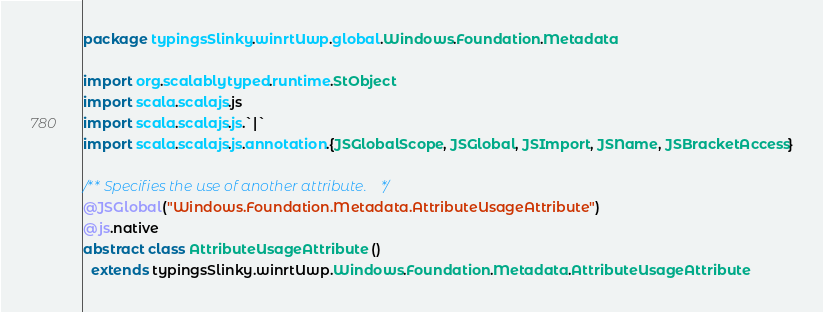Convert code to text. <code><loc_0><loc_0><loc_500><loc_500><_Scala_>package typingsSlinky.winrtUwp.global.Windows.Foundation.Metadata

import org.scalablytyped.runtime.StObject
import scala.scalajs.js
import scala.scalajs.js.`|`
import scala.scalajs.js.annotation.{JSGlobalScope, JSGlobal, JSImport, JSName, JSBracketAccess}

/** Specifies the use of another attribute. */
@JSGlobal("Windows.Foundation.Metadata.AttributeUsageAttribute")
@js.native
abstract class AttributeUsageAttribute ()
  extends typingsSlinky.winrtUwp.Windows.Foundation.Metadata.AttributeUsageAttribute
</code> 